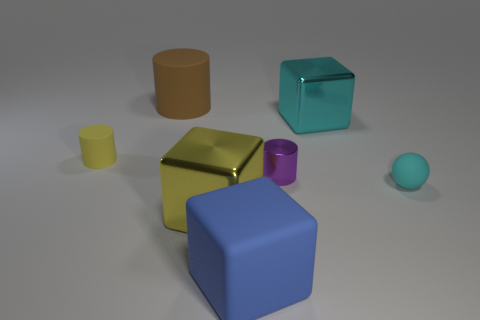Subtract all rubber cylinders. How many cylinders are left? 1 Add 1 big blue rubber blocks. How many objects exist? 8 Subtract all yellow cubes. How many cubes are left? 2 Subtract all spheres. How many objects are left? 6 Subtract 1 cyan cubes. How many objects are left? 6 Subtract 1 blocks. How many blocks are left? 2 Subtract all purple balls. Subtract all blue cylinders. How many balls are left? 1 Subtract all blocks. Subtract all big green metal balls. How many objects are left? 4 Add 7 large cyan metal things. How many large cyan metal things are left? 8 Add 2 purple shiny cylinders. How many purple shiny cylinders exist? 3 